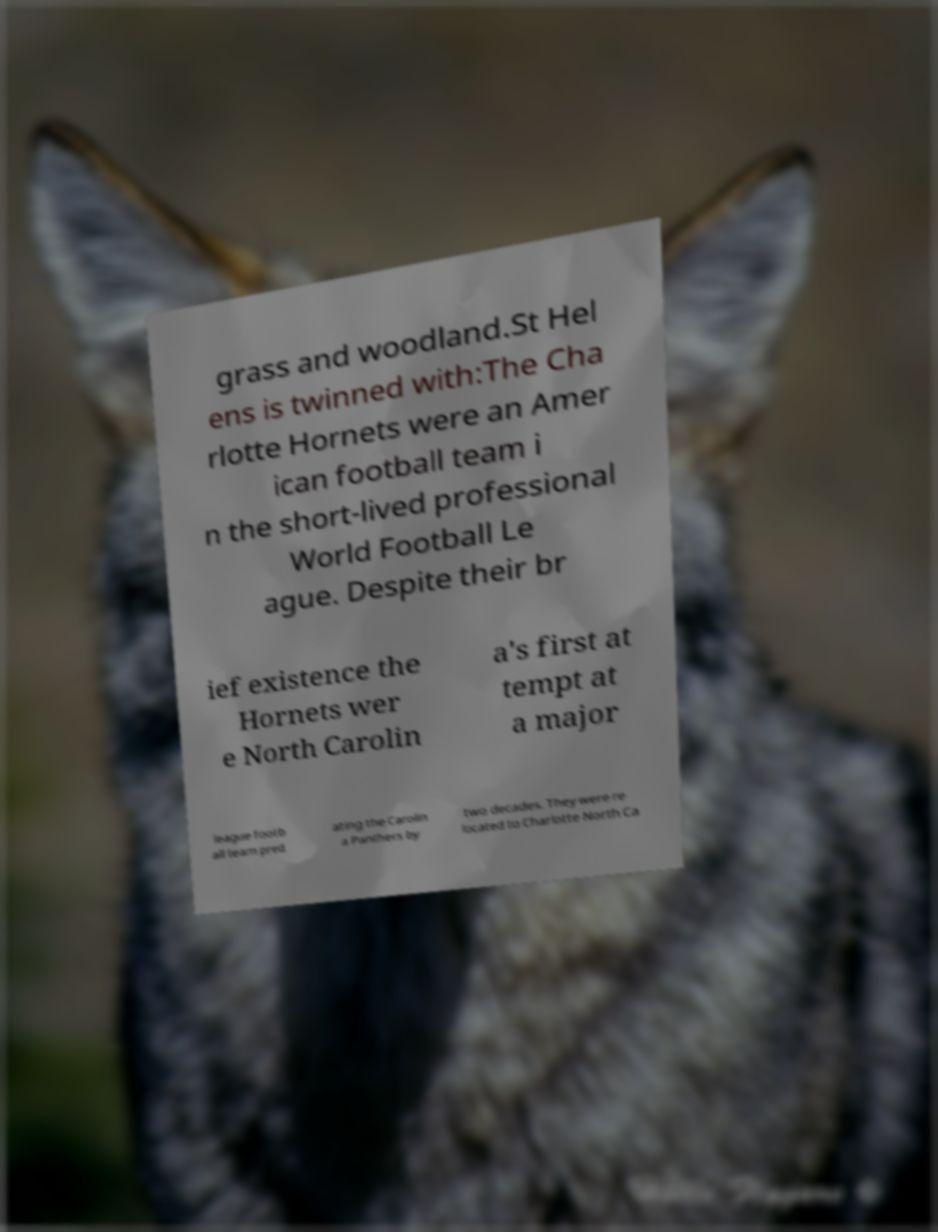Please identify and transcribe the text found in this image. grass and woodland.St Hel ens is twinned with:The Cha rlotte Hornets were an Amer ican football team i n the short-lived professional World Football Le ague. Despite their br ief existence the Hornets wer e North Carolin a's first at tempt at a major league footb all team pred ating the Carolin a Panthers by two decades. They were re located to Charlotte North Ca 